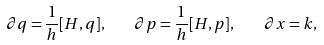<formula> <loc_0><loc_0><loc_500><loc_500>\partial q = \frac { 1 } { h } [ H , q ] , \quad \partial p = \frac { 1 } { h } [ H , p ] , \quad \partial x = k ,</formula> 